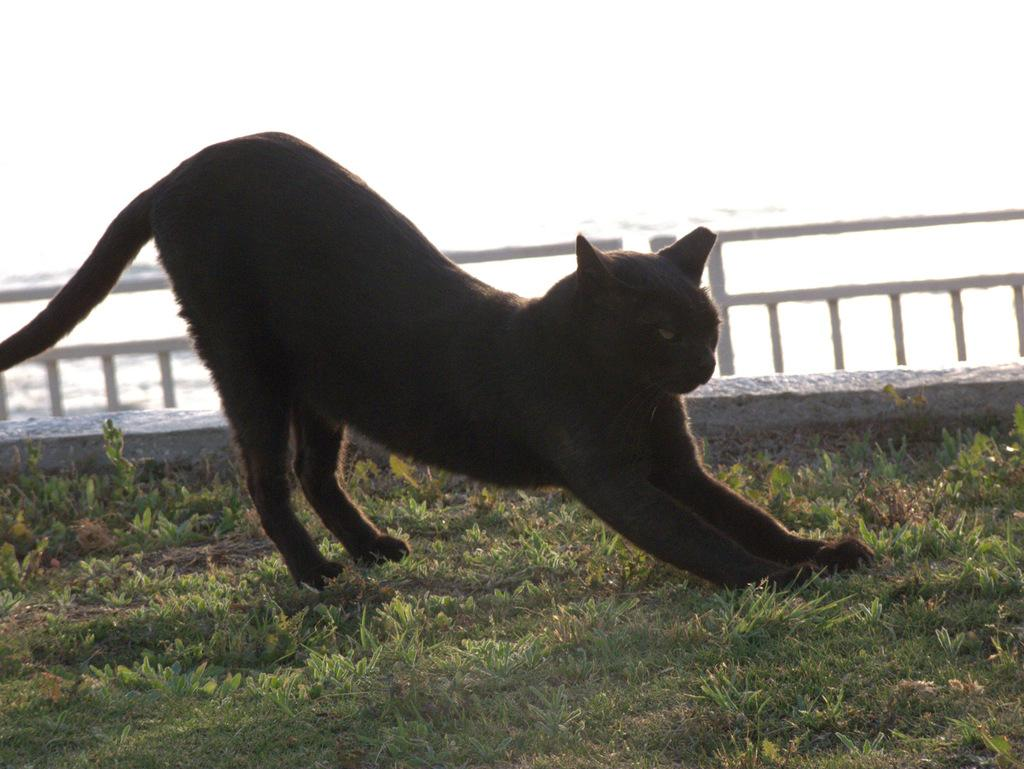What type of animal is on the ground in the image? There is a black cat on the ground in the image. What type of vegetation is visible in the image? There is grass visible in the image, and there are also plants present. What can be seen in the background of the image? There is a fence visible in the image. What song is the minister singing in the image? There is no minister or song present in the image; it features a black cat on the ground with grass, plants, and a fence visible in the background. 